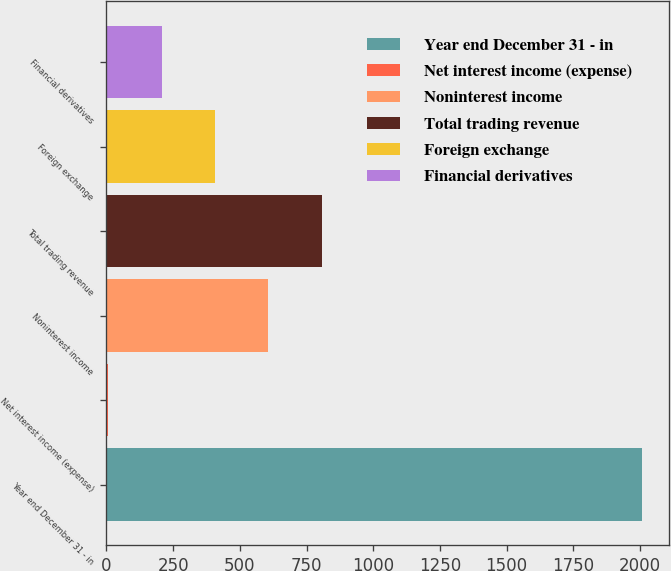Convert chart. <chart><loc_0><loc_0><loc_500><loc_500><bar_chart><fcel>Year end December 31 - in<fcel>Net interest income (expense)<fcel>Noninterest income<fcel>Total trading revenue<fcel>Foreign exchange<fcel>Financial derivatives<nl><fcel>2007<fcel>7<fcel>607<fcel>807<fcel>407<fcel>207<nl></chart> 